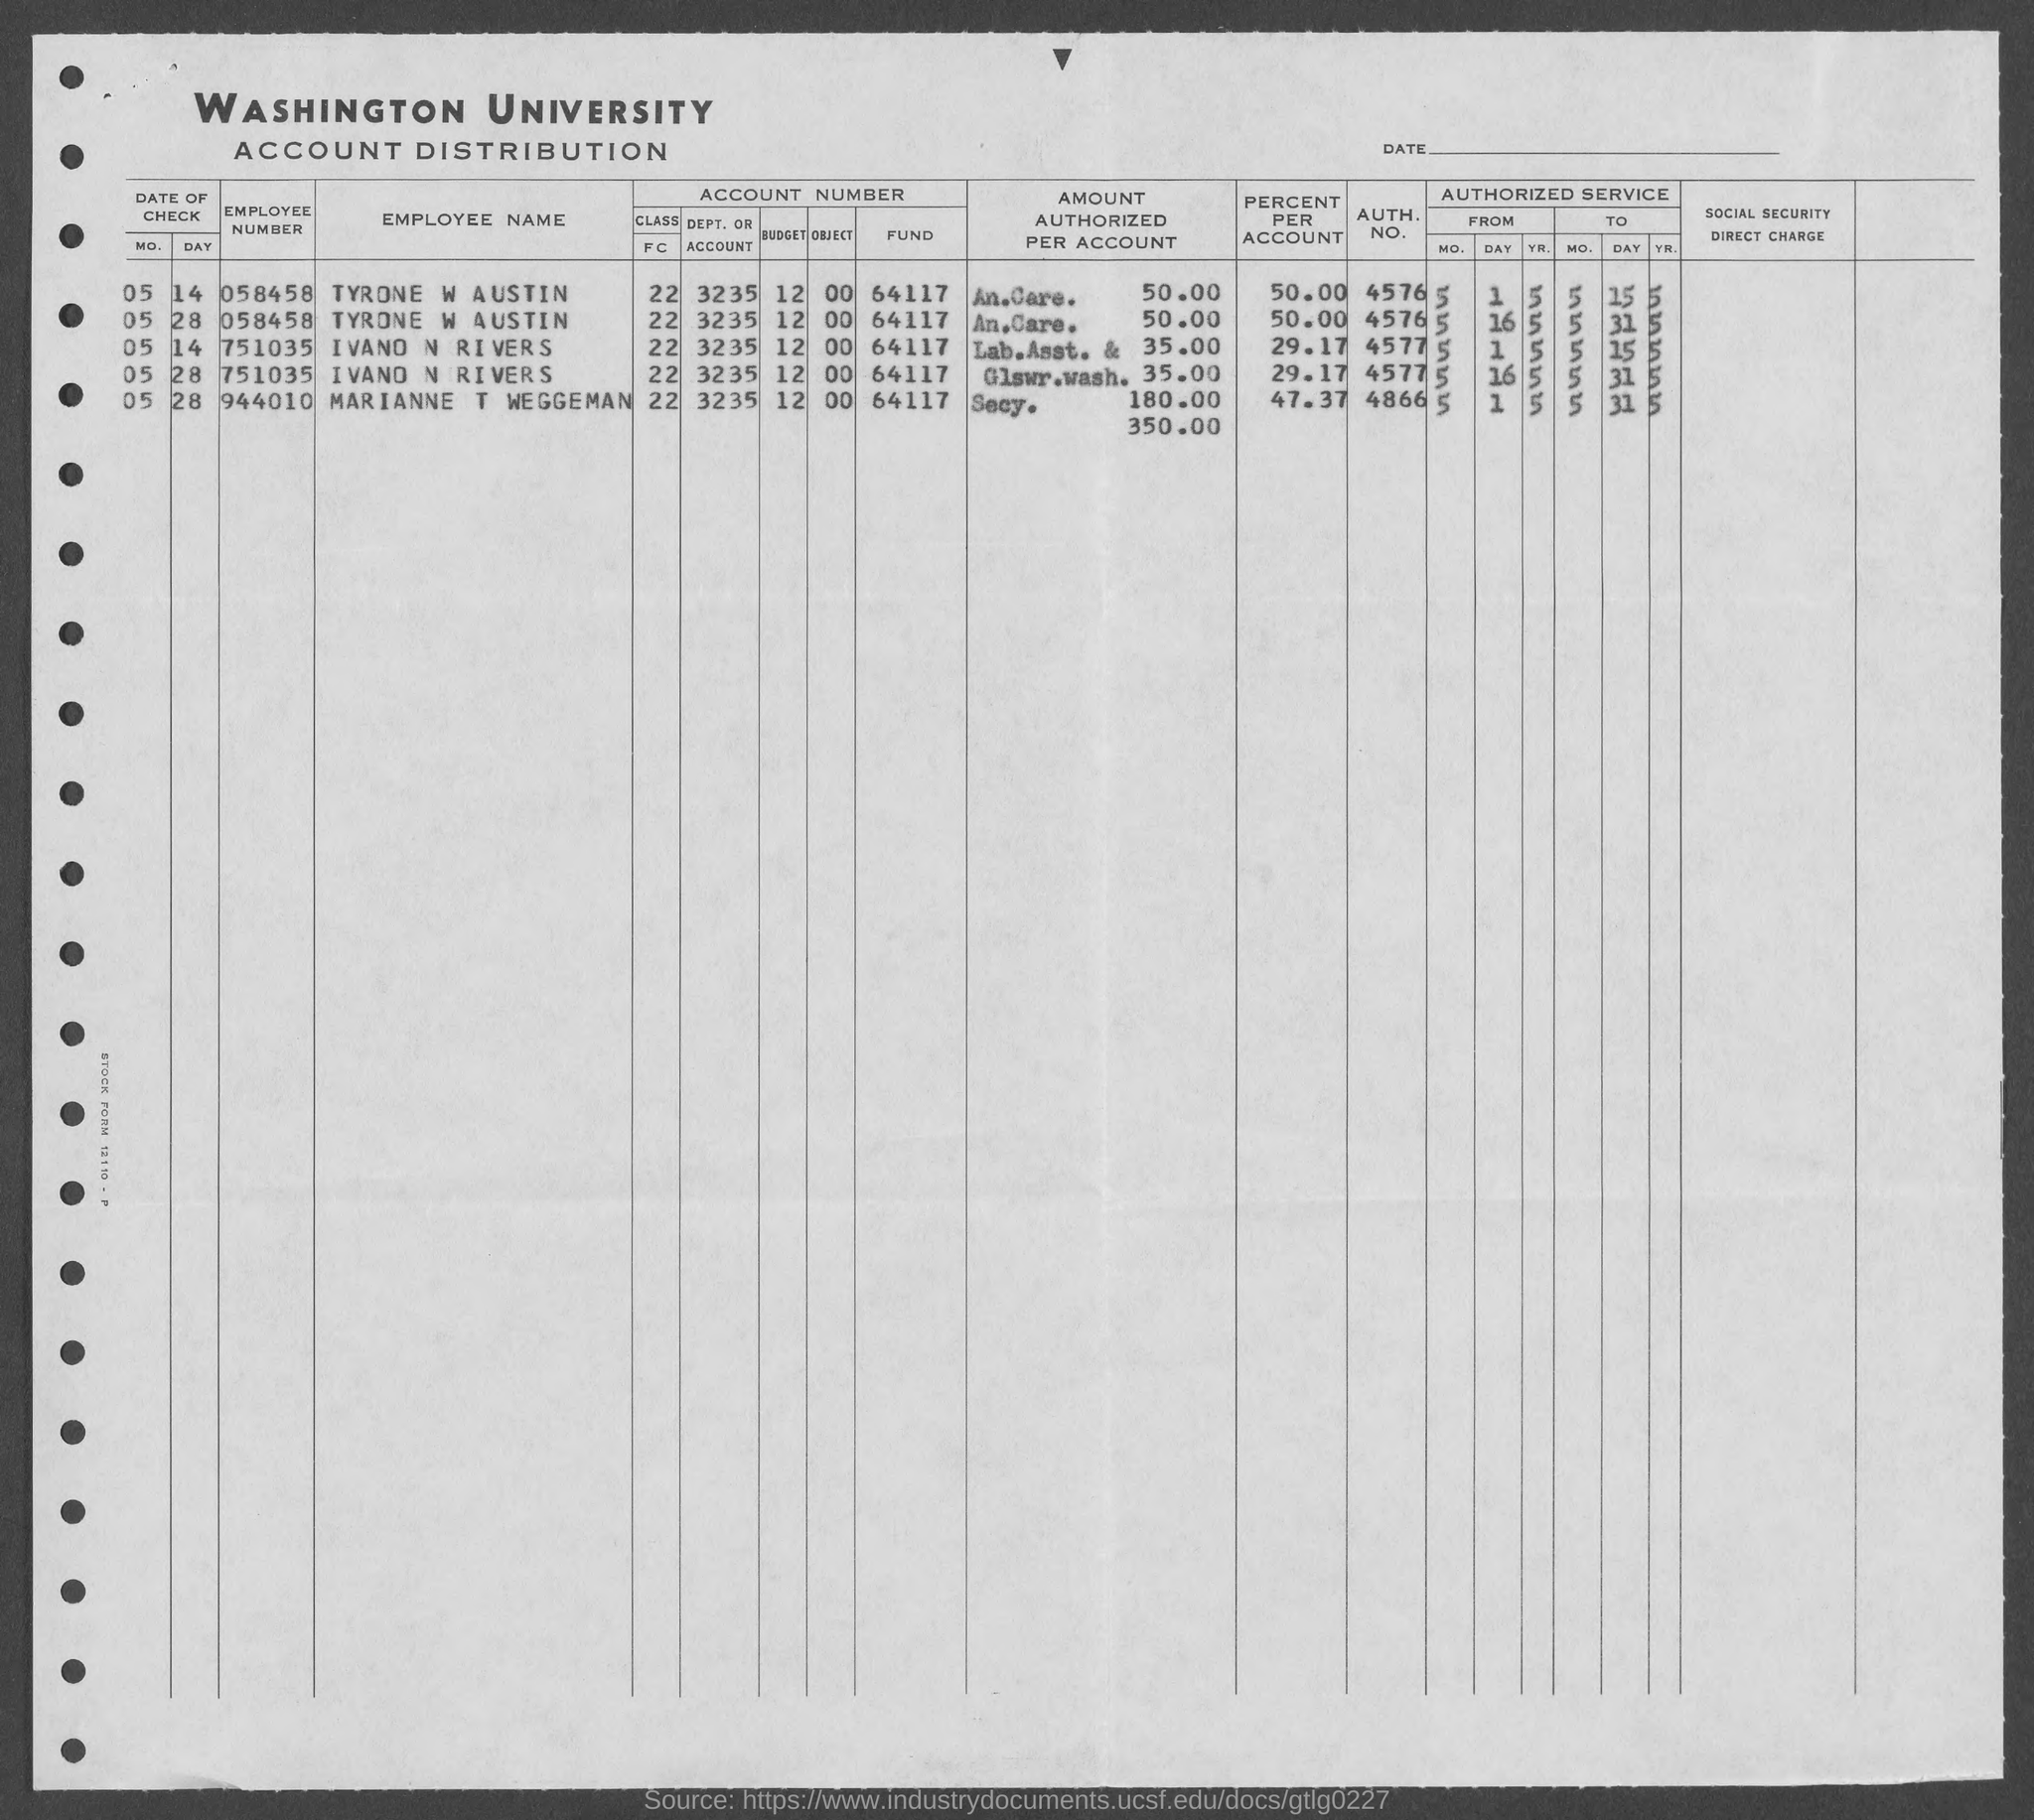Which university's account distirbution is given here?
Provide a short and direct response. WASHINGTON UNIVERSITY. What is the employee number of TYRONE W AUSTIN?
Your answer should be compact. 058458. What is the employee number of IVANO N RIVERS?
Make the answer very short. 751035. What is the AUTH. NO. of TYRONE W AUSTIN given in the document?
Keep it short and to the point. 4576. What is the percent per account of TYRONE W AUSTIN?
Offer a terse response. 50.00. 